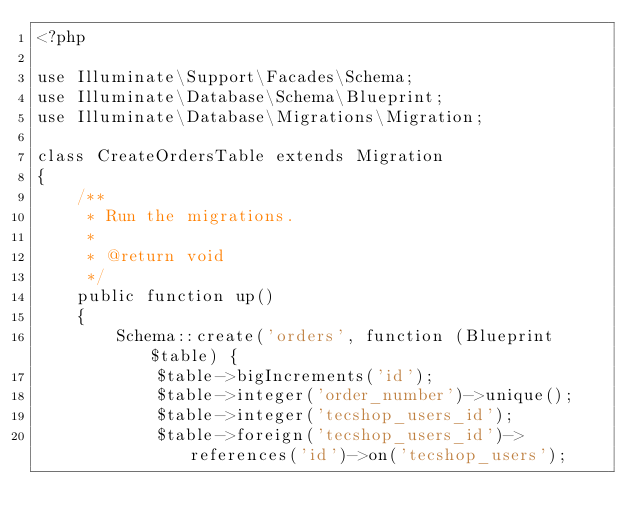<code> <loc_0><loc_0><loc_500><loc_500><_PHP_><?php

use Illuminate\Support\Facades\Schema;
use Illuminate\Database\Schema\Blueprint;
use Illuminate\Database\Migrations\Migration;

class CreateOrdersTable extends Migration
{
    /**
     * Run the migrations.
     *
     * @return void
     */
    public function up()
    {
        Schema::create('orders', function (Blueprint $table) {
            $table->bigIncrements('id');
            $table->integer('order_number')->unique();
            $table->integer('tecshop_users_id');
            $table->foreign('tecshop_users_id')->references('id')->on('tecshop_users');</code> 